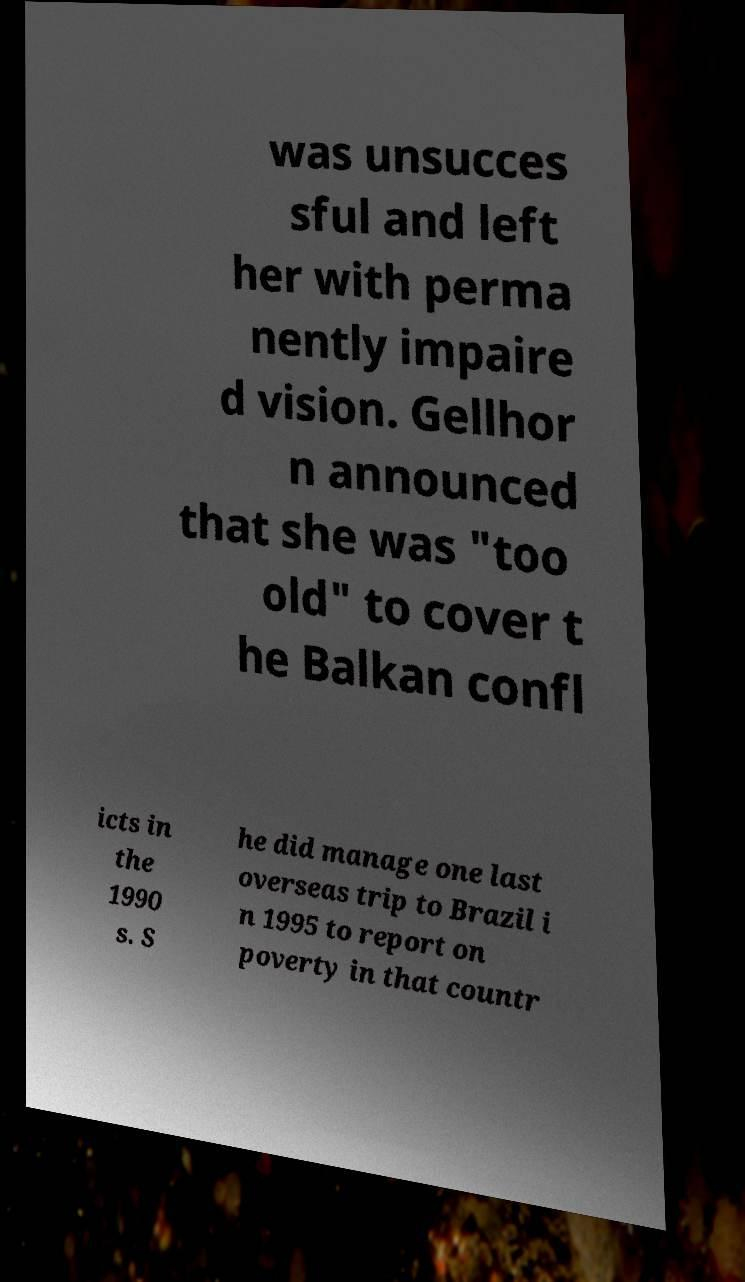Can you accurately transcribe the text from the provided image for me? was unsucces sful and left her with perma nently impaire d vision. Gellhor n announced that she was "too old" to cover t he Balkan confl icts in the 1990 s. S he did manage one last overseas trip to Brazil i n 1995 to report on poverty in that countr 